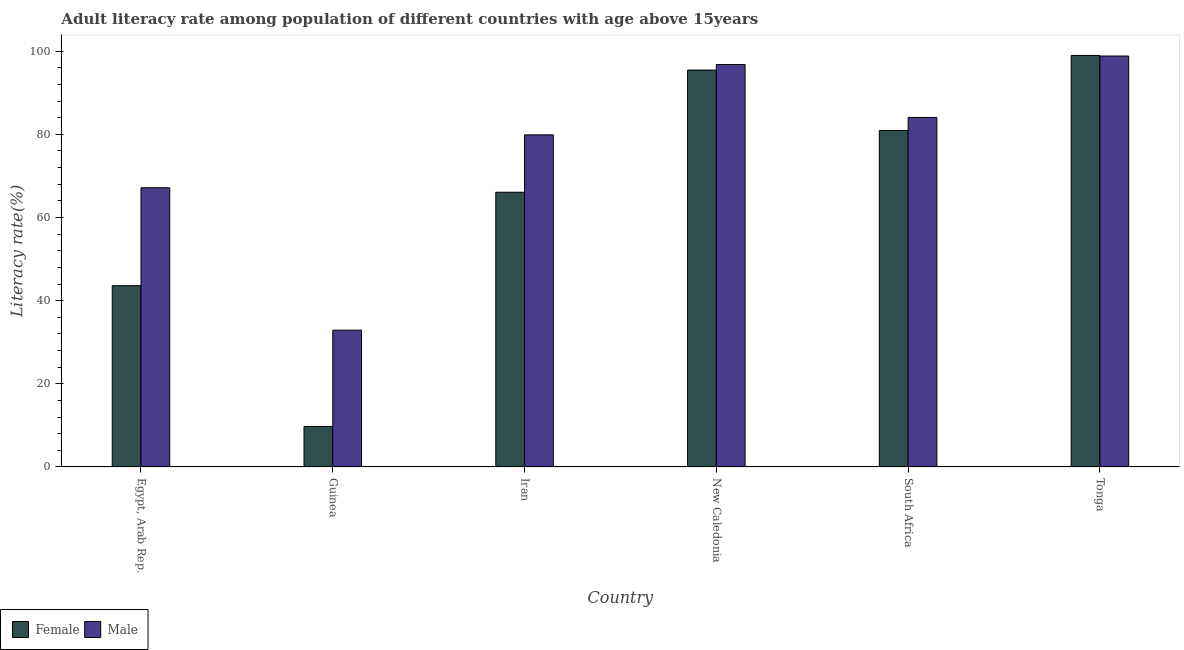How many different coloured bars are there?
Your answer should be very brief. 2. What is the label of the 1st group of bars from the left?
Make the answer very short. Egypt, Arab Rep. What is the female adult literacy rate in South Africa?
Your response must be concise. 80.93. Across all countries, what is the maximum female adult literacy rate?
Your answer should be very brief. 98.98. Across all countries, what is the minimum male adult literacy rate?
Offer a terse response. 32.9. In which country was the male adult literacy rate maximum?
Your response must be concise. Tonga. In which country was the male adult literacy rate minimum?
Your response must be concise. Guinea. What is the total male adult literacy rate in the graph?
Keep it short and to the point. 459.61. What is the difference between the male adult literacy rate in Guinea and that in New Caledonia?
Make the answer very short. -63.89. What is the difference between the male adult literacy rate in Tonga and the female adult literacy rate in Egypt, Arab Rep.?
Your response must be concise. 55.24. What is the average female adult literacy rate per country?
Your answer should be very brief. 65.8. What is the difference between the female adult literacy rate and male adult literacy rate in South Africa?
Ensure brevity in your answer.  -3.14. What is the ratio of the female adult literacy rate in Egypt, Arab Rep. to that in Tonga?
Offer a very short reply. 0.44. Is the difference between the female adult literacy rate in Egypt, Arab Rep. and Tonga greater than the difference between the male adult literacy rate in Egypt, Arab Rep. and Tonga?
Ensure brevity in your answer.  No. What is the difference between the highest and the second highest female adult literacy rate?
Your answer should be compact. 3.51. What is the difference between the highest and the lowest male adult literacy rate?
Your answer should be compact. 65.94. Is the sum of the male adult literacy rate in Egypt, Arab Rep. and Iran greater than the maximum female adult literacy rate across all countries?
Offer a terse response. Yes. How many bars are there?
Your answer should be very brief. 12. Does the graph contain grids?
Provide a short and direct response. No. How many legend labels are there?
Provide a succinct answer. 2. What is the title of the graph?
Keep it short and to the point. Adult literacy rate among population of different countries with age above 15years. Does "Primary school" appear as one of the legend labels in the graph?
Offer a terse response. No. What is the label or title of the X-axis?
Your answer should be compact. Country. What is the label or title of the Y-axis?
Provide a succinct answer. Literacy rate(%). What is the Literacy rate(%) in Female in Egypt, Arab Rep.?
Provide a succinct answer. 43.6. What is the Literacy rate(%) of Male in Egypt, Arab Rep.?
Your answer should be compact. 67.15. What is the Literacy rate(%) in Female in Guinea?
Offer a terse response. 9.74. What is the Literacy rate(%) of Male in Guinea?
Keep it short and to the point. 32.9. What is the Literacy rate(%) of Female in Iran?
Provide a short and direct response. 66.07. What is the Literacy rate(%) of Male in Iran?
Offer a very short reply. 79.87. What is the Literacy rate(%) of Female in New Caledonia?
Make the answer very short. 95.47. What is the Literacy rate(%) in Male in New Caledonia?
Keep it short and to the point. 96.78. What is the Literacy rate(%) in Female in South Africa?
Offer a terse response. 80.93. What is the Literacy rate(%) in Male in South Africa?
Your response must be concise. 84.07. What is the Literacy rate(%) in Female in Tonga?
Your answer should be very brief. 98.98. What is the Literacy rate(%) in Male in Tonga?
Offer a very short reply. 98.83. Across all countries, what is the maximum Literacy rate(%) in Female?
Keep it short and to the point. 98.98. Across all countries, what is the maximum Literacy rate(%) in Male?
Make the answer very short. 98.83. Across all countries, what is the minimum Literacy rate(%) in Female?
Offer a very short reply. 9.74. Across all countries, what is the minimum Literacy rate(%) in Male?
Make the answer very short. 32.9. What is the total Literacy rate(%) in Female in the graph?
Your answer should be compact. 394.78. What is the total Literacy rate(%) of Male in the graph?
Give a very brief answer. 459.61. What is the difference between the Literacy rate(%) in Female in Egypt, Arab Rep. and that in Guinea?
Your answer should be very brief. 33.85. What is the difference between the Literacy rate(%) of Male in Egypt, Arab Rep. and that in Guinea?
Make the answer very short. 34.26. What is the difference between the Literacy rate(%) in Female in Egypt, Arab Rep. and that in Iran?
Your answer should be very brief. -22.47. What is the difference between the Literacy rate(%) in Male in Egypt, Arab Rep. and that in Iran?
Provide a short and direct response. -12.72. What is the difference between the Literacy rate(%) in Female in Egypt, Arab Rep. and that in New Caledonia?
Your answer should be compact. -51.87. What is the difference between the Literacy rate(%) in Male in Egypt, Arab Rep. and that in New Caledonia?
Your answer should be compact. -29.63. What is the difference between the Literacy rate(%) of Female in Egypt, Arab Rep. and that in South Africa?
Provide a short and direct response. -37.33. What is the difference between the Literacy rate(%) in Male in Egypt, Arab Rep. and that in South Africa?
Keep it short and to the point. -16.92. What is the difference between the Literacy rate(%) in Female in Egypt, Arab Rep. and that in Tonga?
Your response must be concise. -55.38. What is the difference between the Literacy rate(%) in Male in Egypt, Arab Rep. and that in Tonga?
Ensure brevity in your answer.  -31.68. What is the difference between the Literacy rate(%) of Female in Guinea and that in Iran?
Your answer should be compact. -56.32. What is the difference between the Literacy rate(%) of Male in Guinea and that in Iran?
Give a very brief answer. -46.98. What is the difference between the Literacy rate(%) of Female in Guinea and that in New Caledonia?
Your answer should be very brief. -85.72. What is the difference between the Literacy rate(%) in Male in Guinea and that in New Caledonia?
Ensure brevity in your answer.  -63.89. What is the difference between the Literacy rate(%) of Female in Guinea and that in South Africa?
Your answer should be very brief. -71.19. What is the difference between the Literacy rate(%) of Male in Guinea and that in South Africa?
Make the answer very short. -51.18. What is the difference between the Literacy rate(%) in Female in Guinea and that in Tonga?
Ensure brevity in your answer.  -89.23. What is the difference between the Literacy rate(%) in Male in Guinea and that in Tonga?
Keep it short and to the point. -65.94. What is the difference between the Literacy rate(%) of Female in Iran and that in New Caledonia?
Provide a short and direct response. -29.4. What is the difference between the Literacy rate(%) in Male in Iran and that in New Caledonia?
Ensure brevity in your answer.  -16.91. What is the difference between the Literacy rate(%) in Female in Iran and that in South Africa?
Provide a succinct answer. -14.86. What is the difference between the Literacy rate(%) of Male in Iran and that in South Africa?
Make the answer very short. -4.2. What is the difference between the Literacy rate(%) of Female in Iran and that in Tonga?
Your answer should be compact. -32.91. What is the difference between the Literacy rate(%) of Male in Iran and that in Tonga?
Your answer should be compact. -18.96. What is the difference between the Literacy rate(%) of Female in New Caledonia and that in South Africa?
Your answer should be compact. 14.54. What is the difference between the Literacy rate(%) of Male in New Caledonia and that in South Africa?
Provide a succinct answer. 12.71. What is the difference between the Literacy rate(%) in Female in New Caledonia and that in Tonga?
Make the answer very short. -3.51. What is the difference between the Literacy rate(%) of Male in New Caledonia and that in Tonga?
Give a very brief answer. -2.05. What is the difference between the Literacy rate(%) of Female in South Africa and that in Tonga?
Your answer should be very brief. -18.05. What is the difference between the Literacy rate(%) of Male in South Africa and that in Tonga?
Provide a short and direct response. -14.76. What is the difference between the Literacy rate(%) of Female in Egypt, Arab Rep. and the Literacy rate(%) of Male in Guinea?
Ensure brevity in your answer.  10.7. What is the difference between the Literacy rate(%) in Female in Egypt, Arab Rep. and the Literacy rate(%) in Male in Iran?
Offer a terse response. -36.28. What is the difference between the Literacy rate(%) of Female in Egypt, Arab Rep. and the Literacy rate(%) of Male in New Caledonia?
Ensure brevity in your answer.  -53.19. What is the difference between the Literacy rate(%) in Female in Egypt, Arab Rep. and the Literacy rate(%) in Male in South Africa?
Offer a very short reply. -40.48. What is the difference between the Literacy rate(%) in Female in Egypt, Arab Rep. and the Literacy rate(%) in Male in Tonga?
Offer a terse response. -55.24. What is the difference between the Literacy rate(%) of Female in Guinea and the Literacy rate(%) of Male in Iran?
Your response must be concise. -70.13. What is the difference between the Literacy rate(%) of Female in Guinea and the Literacy rate(%) of Male in New Caledonia?
Provide a succinct answer. -87.04. What is the difference between the Literacy rate(%) in Female in Guinea and the Literacy rate(%) in Male in South Africa?
Keep it short and to the point. -74.33. What is the difference between the Literacy rate(%) in Female in Guinea and the Literacy rate(%) in Male in Tonga?
Offer a terse response. -89.09. What is the difference between the Literacy rate(%) in Female in Iran and the Literacy rate(%) in Male in New Caledonia?
Provide a short and direct response. -30.72. What is the difference between the Literacy rate(%) of Female in Iran and the Literacy rate(%) of Male in South Africa?
Provide a succinct answer. -18. What is the difference between the Literacy rate(%) in Female in Iran and the Literacy rate(%) in Male in Tonga?
Provide a succinct answer. -32.77. What is the difference between the Literacy rate(%) of Female in New Caledonia and the Literacy rate(%) of Male in South Africa?
Provide a short and direct response. 11.39. What is the difference between the Literacy rate(%) in Female in New Caledonia and the Literacy rate(%) in Male in Tonga?
Offer a terse response. -3.37. What is the difference between the Literacy rate(%) in Female in South Africa and the Literacy rate(%) in Male in Tonga?
Provide a short and direct response. -17.91. What is the average Literacy rate(%) in Female per country?
Your response must be concise. 65.8. What is the average Literacy rate(%) of Male per country?
Your answer should be very brief. 76.6. What is the difference between the Literacy rate(%) in Female and Literacy rate(%) in Male in Egypt, Arab Rep.?
Provide a short and direct response. -23.56. What is the difference between the Literacy rate(%) in Female and Literacy rate(%) in Male in Guinea?
Keep it short and to the point. -23.15. What is the difference between the Literacy rate(%) of Female and Literacy rate(%) of Male in Iran?
Offer a very short reply. -13.8. What is the difference between the Literacy rate(%) in Female and Literacy rate(%) in Male in New Caledonia?
Ensure brevity in your answer.  -1.32. What is the difference between the Literacy rate(%) of Female and Literacy rate(%) of Male in South Africa?
Offer a terse response. -3.14. What is the difference between the Literacy rate(%) of Female and Literacy rate(%) of Male in Tonga?
Your answer should be compact. 0.14. What is the ratio of the Literacy rate(%) in Female in Egypt, Arab Rep. to that in Guinea?
Offer a very short reply. 4.47. What is the ratio of the Literacy rate(%) of Male in Egypt, Arab Rep. to that in Guinea?
Your response must be concise. 2.04. What is the ratio of the Literacy rate(%) of Female in Egypt, Arab Rep. to that in Iran?
Provide a short and direct response. 0.66. What is the ratio of the Literacy rate(%) in Male in Egypt, Arab Rep. to that in Iran?
Provide a short and direct response. 0.84. What is the ratio of the Literacy rate(%) in Female in Egypt, Arab Rep. to that in New Caledonia?
Ensure brevity in your answer.  0.46. What is the ratio of the Literacy rate(%) of Male in Egypt, Arab Rep. to that in New Caledonia?
Give a very brief answer. 0.69. What is the ratio of the Literacy rate(%) in Female in Egypt, Arab Rep. to that in South Africa?
Ensure brevity in your answer.  0.54. What is the ratio of the Literacy rate(%) of Male in Egypt, Arab Rep. to that in South Africa?
Provide a short and direct response. 0.8. What is the ratio of the Literacy rate(%) in Female in Egypt, Arab Rep. to that in Tonga?
Keep it short and to the point. 0.44. What is the ratio of the Literacy rate(%) of Male in Egypt, Arab Rep. to that in Tonga?
Ensure brevity in your answer.  0.68. What is the ratio of the Literacy rate(%) in Female in Guinea to that in Iran?
Your response must be concise. 0.15. What is the ratio of the Literacy rate(%) of Male in Guinea to that in Iran?
Give a very brief answer. 0.41. What is the ratio of the Literacy rate(%) in Female in Guinea to that in New Caledonia?
Provide a short and direct response. 0.1. What is the ratio of the Literacy rate(%) in Male in Guinea to that in New Caledonia?
Provide a short and direct response. 0.34. What is the ratio of the Literacy rate(%) of Female in Guinea to that in South Africa?
Ensure brevity in your answer.  0.12. What is the ratio of the Literacy rate(%) in Male in Guinea to that in South Africa?
Provide a succinct answer. 0.39. What is the ratio of the Literacy rate(%) of Female in Guinea to that in Tonga?
Make the answer very short. 0.1. What is the ratio of the Literacy rate(%) in Male in Guinea to that in Tonga?
Offer a terse response. 0.33. What is the ratio of the Literacy rate(%) in Female in Iran to that in New Caledonia?
Your answer should be very brief. 0.69. What is the ratio of the Literacy rate(%) in Male in Iran to that in New Caledonia?
Ensure brevity in your answer.  0.83. What is the ratio of the Literacy rate(%) in Female in Iran to that in South Africa?
Give a very brief answer. 0.82. What is the ratio of the Literacy rate(%) of Male in Iran to that in South Africa?
Your answer should be very brief. 0.95. What is the ratio of the Literacy rate(%) of Female in Iran to that in Tonga?
Ensure brevity in your answer.  0.67. What is the ratio of the Literacy rate(%) in Male in Iran to that in Tonga?
Provide a succinct answer. 0.81. What is the ratio of the Literacy rate(%) of Female in New Caledonia to that in South Africa?
Provide a succinct answer. 1.18. What is the ratio of the Literacy rate(%) of Male in New Caledonia to that in South Africa?
Keep it short and to the point. 1.15. What is the ratio of the Literacy rate(%) in Female in New Caledonia to that in Tonga?
Ensure brevity in your answer.  0.96. What is the ratio of the Literacy rate(%) in Male in New Caledonia to that in Tonga?
Offer a very short reply. 0.98. What is the ratio of the Literacy rate(%) of Female in South Africa to that in Tonga?
Offer a terse response. 0.82. What is the ratio of the Literacy rate(%) of Male in South Africa to that in Tonga?
Give a very brief answer. 0.85. What is the difference between the highest and the second highest Literacy rate(%) of Female?
Provide a succinct answer. 3.51. What is the difference between the highest and the second highest Literacy rate(%) in Male?
Make the answer very short. 2.05. What is the difference between the highest and the lowest Literacy rate(%) in Female?
Provide a short and direct response. 89.23. What is the difference between the highest and the lowest Literacy rate(%) of Male?
Your response must be concise. 65.94. 